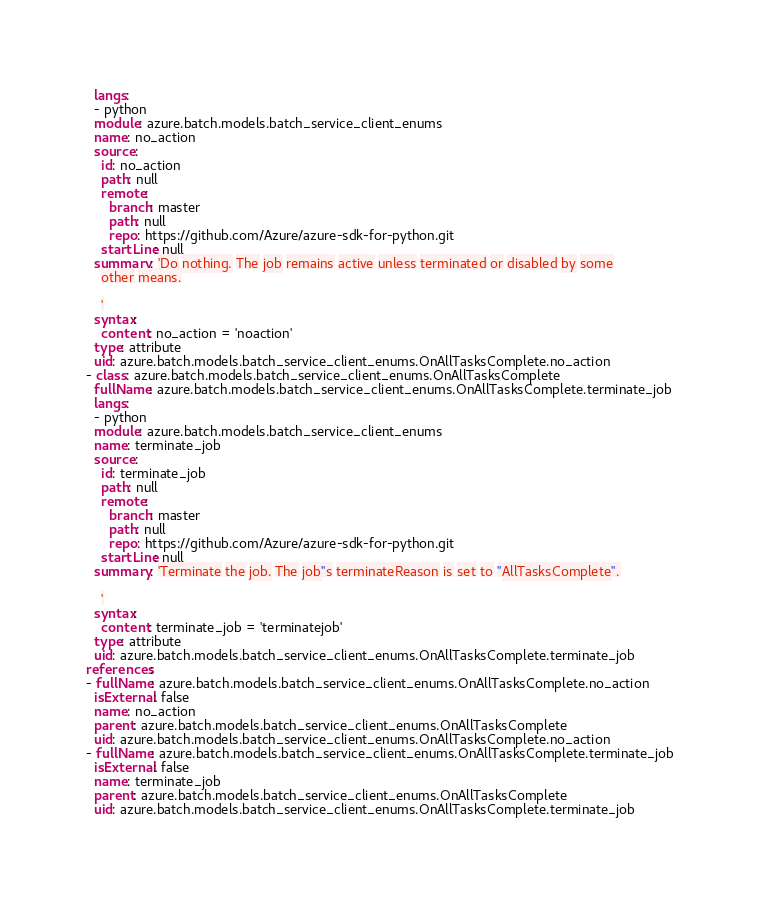Convert code to text. <code><loc_0><loc_0><loc_500><loc_500><_YAML_>  langs:
  - python
  module: azure.batch.models.batch_service_client_enums
  name: no_action
  source:
    id: no_action
    path: null
    remote:
      branch: master
      path: null
      repo: https://github.com/Azure/azure-sdk-for-python.git
    startLine: null
  summary: 'Do nothing. The job remains active unless terminated or disabled by some
    other means.

    '
  syntax:
    content: no_action = 'noaction'
  type: attribute
  uid: azure.batch.models.batch_service_client_enums.OnAllTasksComplete.no_action
- class: azure.batch.models.batch_service_client_enums.OnAllTasksComplete
  fullName: azure.batch.models.batch_service_client_enums.OnAllTasksComplete.terminate_job
  langs:
  - python
  module: azure.batch.models.batch_service_client_enums
  name: terminate_job
  source:
    id: terminate_job
    path: null
    remote:
      branch: master
      path: null
      repo: https://github.com/Azure/azure-sdk-for-python.git
    startLine: null
  summary: 'Terminate the job. The job''s terminateReason is set to ''AllTasksComplete''.

    '
  syntax:
    content: terminate_job = 'terminatejob'
  type: attribute
  uid: azure.batch.models.batch_service_client_enums.OnAllTasksComplete.terminate_job
references:
- fullName: azure.batch.models.batch_service_client_enums.OnAllTasksComplete.no_action
  isExternal: false
  name: no_action
  parent: azure.batch.models.batch_service_client_enums.OnAllTasksComplete
  uid: azure.batch.models.batch_service_client_enums.OnAllTasksComplete.no_action
- fullName: azure.batch.models.batch_service_client_enums.OnAllTasksComplete.terminate_job
  isExternal: false
  name: terminate_job
  parent: azure.batch.models.batch_service_client_enums.OnAllTasksComplete
  uid: azure.batch.models.batch_service_client_enums.OnAllTasksComplete.terminate_job
</code> 